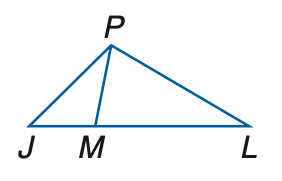Answer the mathemtical geometry problem and directly provide the correct option letter.
Question: In the figure, J M \cong P M and M L \cong P L. If m \angle P L J = 34, find m \angle J P M.
Choices: A: 34 B: 34.5 C: 36 D: 36.5 D 